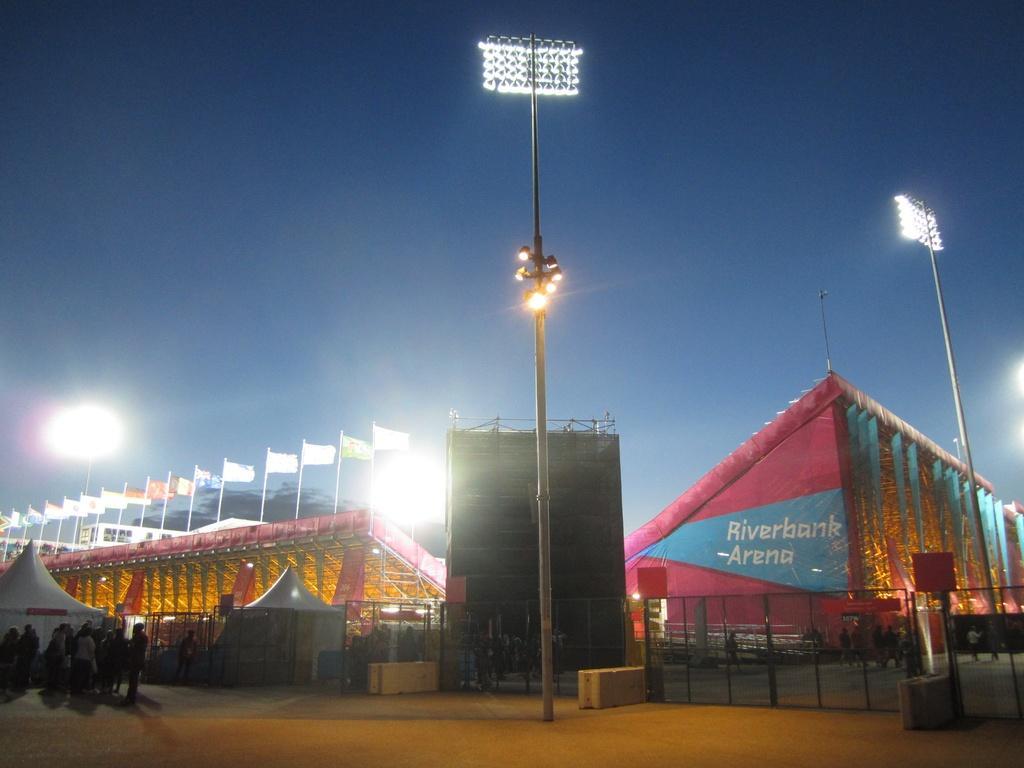Could you give a brief overview of what you see in this image? In this image we can see a stadium, where are gates, floodlights, flags, poles, tents, there are a few people, also we can see the sky. 